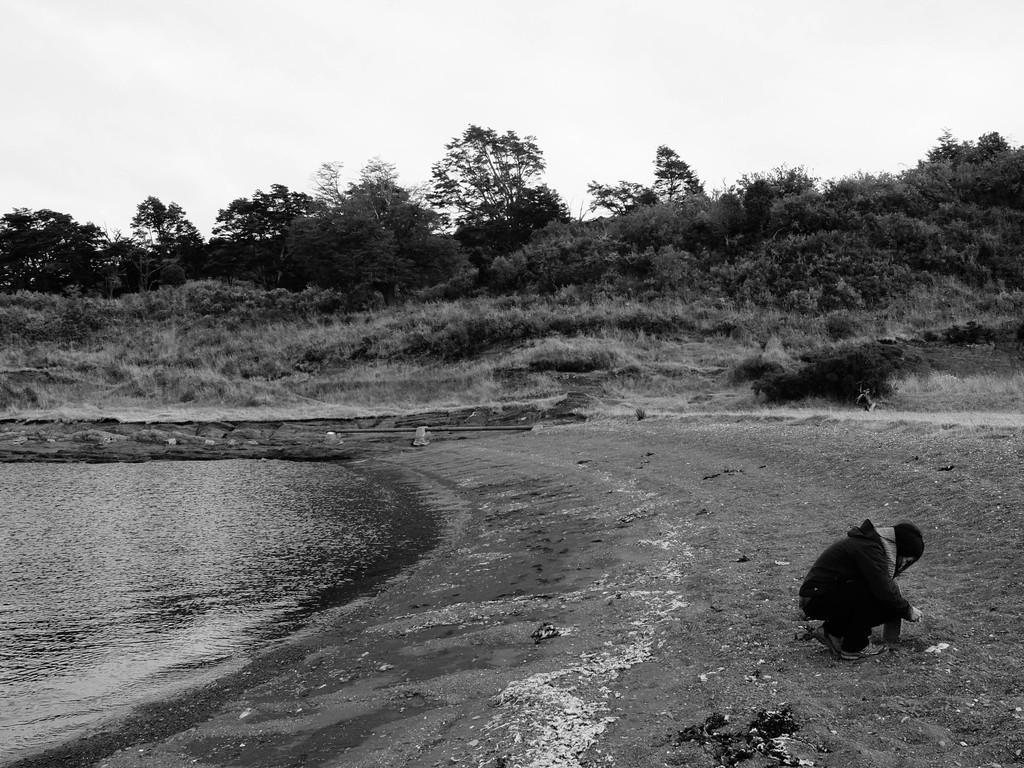Please provide a concise description of this image. On the right side of the image we can see a person sitting on the ground. On the left there is a river. In the background there are trees and sky. 